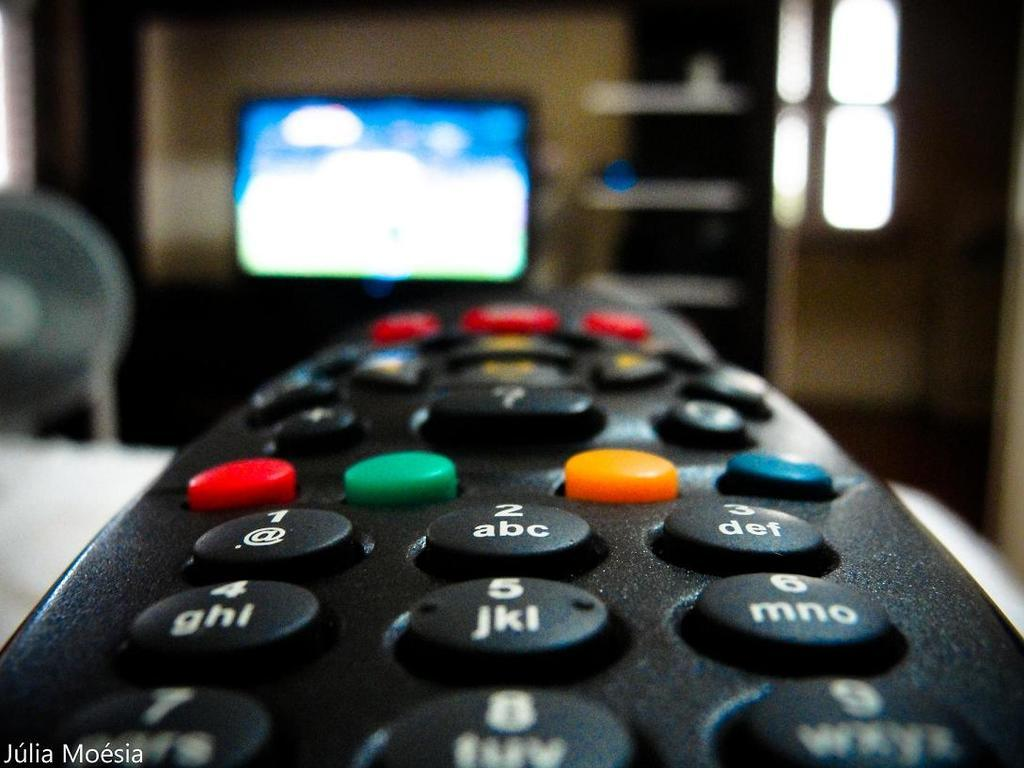<image>
Summarize the visual content of the image. A close up view of a black remote control with and @ symbol on the button 1. 